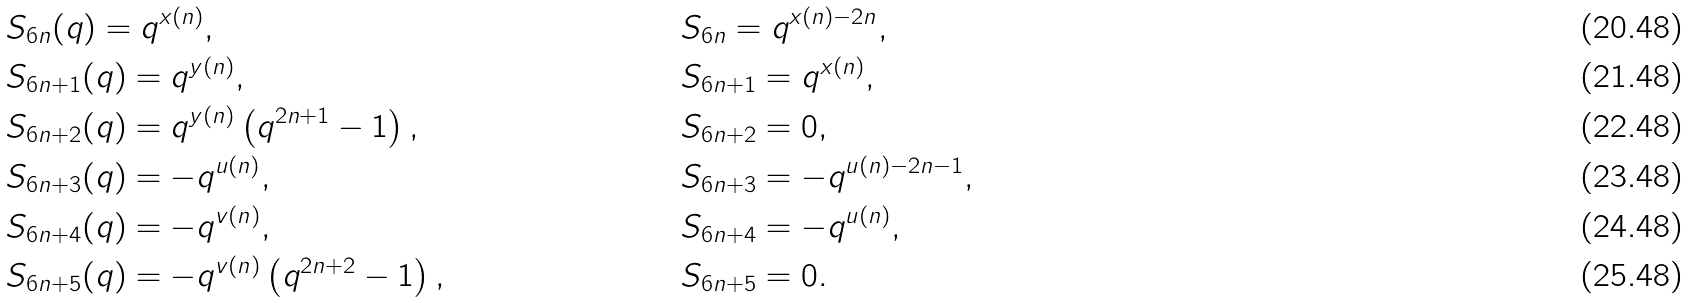Convert formula to latex. <formula><loc_0><loc_0><loc_500><loc_500>& S _ { 6 n } ( q ) = q ^ { x ( n ) } , & & S _ { 6 n } = q ^ { x ( n ) - 2 n } , & & & \\ & S _ { 6 n + 1 } ( q ) = q ^ { y ( n ) } , & & S _ { 6 n + 1 } = q ^ { x ( n ) } , & & & \\ & S _ { 6 n + 2 } ( q ) = q ^ { y ( n ) } \left ( q ^ { 2 n + 1 } - 1 \right ) , & & S _ { 6 n + 2 } = 0 , & & & \\ & S _ { 6 n + 3 } ( q ) = - q ^ { u ( n ) } , & & S _ { 6 n + 3 } = - q ^ { u ( n ) - 2 n - 1 } , & & & \\ & S _ { 6 n + 4 } ( q ) = - q ^ { v ( n ) } , & & S _ { 6 n + 4 } = - q ^ { u ( n ) } , & & & \\ & S _ { 6 n + 5 } ( q ) = - q ^ { v ( n ) } \left ( q ^ { 2 n + 2 } - 1 \right ) , & & S _ { 6 n + 5 } = 0 . & & &</formula> 